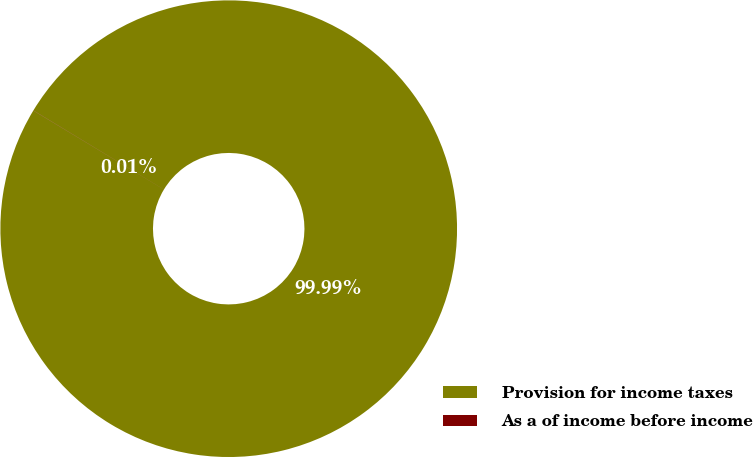<chart> <loc_0><loc_0><loc_500><loc_500><pie_chart><fcel>Provision for income taxes<fcel>As a of income before income<nl><fcel>99.99%<fcel>0.01%<nl></chart> 